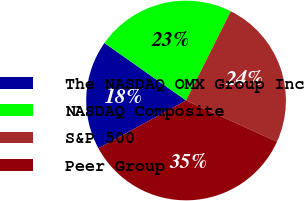<chart> <loc_0><loc_0><loc_500><loc_500><pie_chart><fcel>The NASDAQ OMX Group Inc<fcel>NASDAQ Composite<fcel>S&P 500<fcel>Peer Group<nl><fcel>17.72%<fcel>22.63%<fcel>24.38%<fcel>35.27%<nl></chart> 